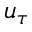<formula> <loc_0><loc_0><loc_500><loc_500>u _ { \tau }</formula> 